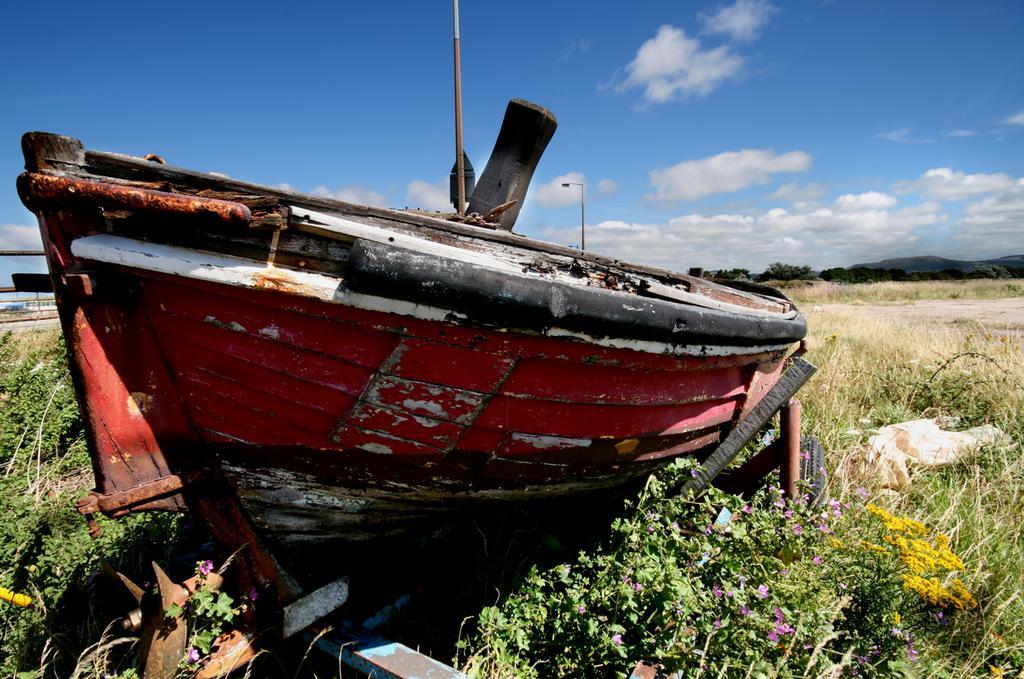In one or two sentences, can you explain what this image depicts? In this image in front there is a boat. There are plants and flowers. At the bottom of the image there is grass on the surface. In the background of the image there are trees, mountains and sky. On the left side of the image there is water. 